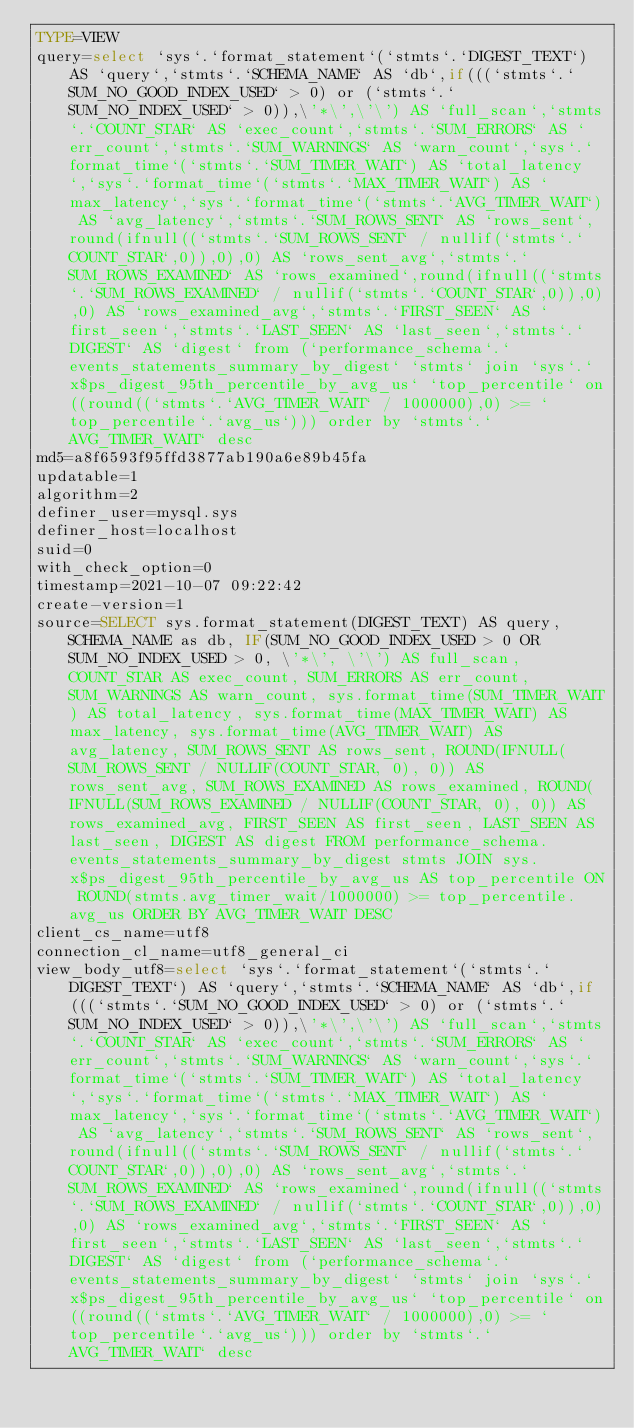<code> <loc_0><loc_0><loc_500><loc_500><_VisualBasic_>TYPE=VIEW
query=select `sys`.`format_statement`(`stmts`.`DIGEST_TEXT`) AS `query`,`stmts`.`SCHEMA_NAME` AS `db`,if(((`stmts`.`SUM_NO_GOOD_INDEX_USED` > 0) or (`stmts`.`SUM_NO_INDEX_USED` > 0)),\'*\',\'\') AS `full_scan`,`stmts`.`COUNT_STAR` AS `exec_count`,`stmts`.`SUM_ERRORS` AS `err_count`,`stmts`.`SUM_WARNINGS` AS `warn_count`,`sys`.`format_time`(`stmts`.`SUM_TIMER_WAIT`) AS `total_latency`,`sys`.`format_time`(`stmts`.`MAX_TIMER_WAIT`) AS `max_latency`,`sys`.`format_time`(`stmts`.`AVG_TIMER_WAIT`) AS `avg_latency`,`stmts`.`SUM_ROWS_SENT` AS `rows_sent`,round(ifnull((`stmts`.`SUM_ROWS_SENT` / nullif(`stmts`.`COUNT_STAR`,0)),0),0) AS `rows_sent_avg`,`stmts`.`SUM_ROWS_EXAMINED` AS `rows_examined`,round(ifnull((`stmts`.`SUM_ROWS_EXAMINED` / nullif(`stmts`.`COUNT_STAR`,0)),0),0) AS `rows_examined_avg`,`stmts`.`FIRST_SEEN` AS `first_seen`,`stmts`.`LAST_SEEN` AS `last_seen`,`stmts`.`DIGEST` AS `digest` from (`performance_schema`.`events_statements_summary_by_digest` `stmts` join `sys`.`x$ps_digest_95th_percentile_by_avg_us` `top_percentile` on((round((`stmts`.`AVG_TIMER_WAIT` / 1000000),0) >= `top_percentile`.`avg_us`))) order by `stmts`.`AVG_TIMER_WAIT` desc
md5=a8f6593f95ffd3877ab190a6e89b45fa
updatable=1
algorithm=2
definer_user=mysql.sys
definer_host=localhost
suid=0
with_check_option=0
timestamp=2021-10-07 09:22:42
create-version=1
source=SELECT sys.format_statement(DIGEST_TEXT) AS query, SCHEMA_NAME as db, IF(SUM_NO_GOOD_INDEX_USED > 0 OR SUM_NO_INDEX_USED > 0, \'*\', \'\') AS full_scan, COUNT_STAR AS exec_count, SUM_ERRORS AS err_count, SUM_WARNINGS AS warn_count, sys.format_time(SUM_TIMER_WAIT) AS total_latency, sys.format_time(MAX_TIMER_WAIT) AS max_latency, sys.format_time(AVG_TIMER_WAIT) AS avg_latency, SUM_ROWS_SENT AS rows_sent, ROUND(IFNULL(SUM_ROWS_SENT / NULLIF(COUNT_STAR, 0), 0)) AS rows_sent_avg, SUM_ROWS_EXAMINED AS rows_examined, ROUND(IFNULL(SUM_ROWS_EXAMINED / NULLIF(COUNT_STAR, 0), 0)) AS rows_examined_avg, FIRST_SEEN AS first_seen, LAST_SEEN AS last_seen, DIGEST AS digest FROM performance_schema.events_statements_summary_by_digest stmts JOIN sys.x$ps_digest_95th_percentile_by_avg_us AS top_percentile ON ROUND(stmts.avg_timer_wait/1000000) >= top_percentile.avg_us ORDER BY AVG_TIMER_WAIT DESC
client_cs_name=utf8
connection_cl_name=utf8_general_ci
view_body_utf8=select `sys`.`format_statement`(`stmts`.`DIGEST_TEXT`) AS `query`,`stmts`.`SCHEMA_NAME` AS `db`,if(((`stmts`.`SUM_NO_GOOD_INDEX_USED` > 0) or (`stmts`.`SUM_NO_INDEX_USED` > 0)),\'*\',\'\') AS `full_scan`,`stmts`.`COUNT_STAR` AS `exec_count`,`stmts`.`SUM_ERRORS` AS `err_count`,`stmts`.`SUM_WARNINGS` AS `warn_count`,`sys`.`format_time`(`stmts`.`SUM_TIMER_WAIT`) AS `total_latency`,`sys`.`format_time`(`stmts`.`MAX_TIMER_WAIT`) AS `max_latency`,`sys`.`format_time`(`stmts`.`AVG_TIMER_WAIT`) AS `avg_latency`,`stmts`.`SUM_ROWS_SENT` AS `rows_sent`,round(ifnull((`stmts`.`SUM_ROWS_SENT` / nullif(`stmts`.`COUNT_STAR`,0)),0),0) AS `rows_sent_avg`,`stmts`.`SUM_ROWS_EXAMINED` AS `rows_examined`,round(ifnull((`stmts`.`SUM_ROWS_EXAMINED` / nullif(`stmts`.`COUNT_STAR`,0)),0),0) AS `rows_examined_avg`,`stmts`.`FIRST_SEEN` AS `first_seen`,`stmts`.`LAST_SEEN` AS `last_seen`,`stmts`.`DIGEST` AS `digest` from (`performance_schema`.`events_statements_summary_by_digest` `stmts` join `sys`.`x$ps_digest_95th_percentile_by_avg_us` `top_percentile` on((round((`stmts`.`AVG_TIMER_WAIT` / 1000000),0) >= `top_percentile`.`avg_us`))) order by `stmts`.`AVG_TIMER_WAIT` desc
</code> 